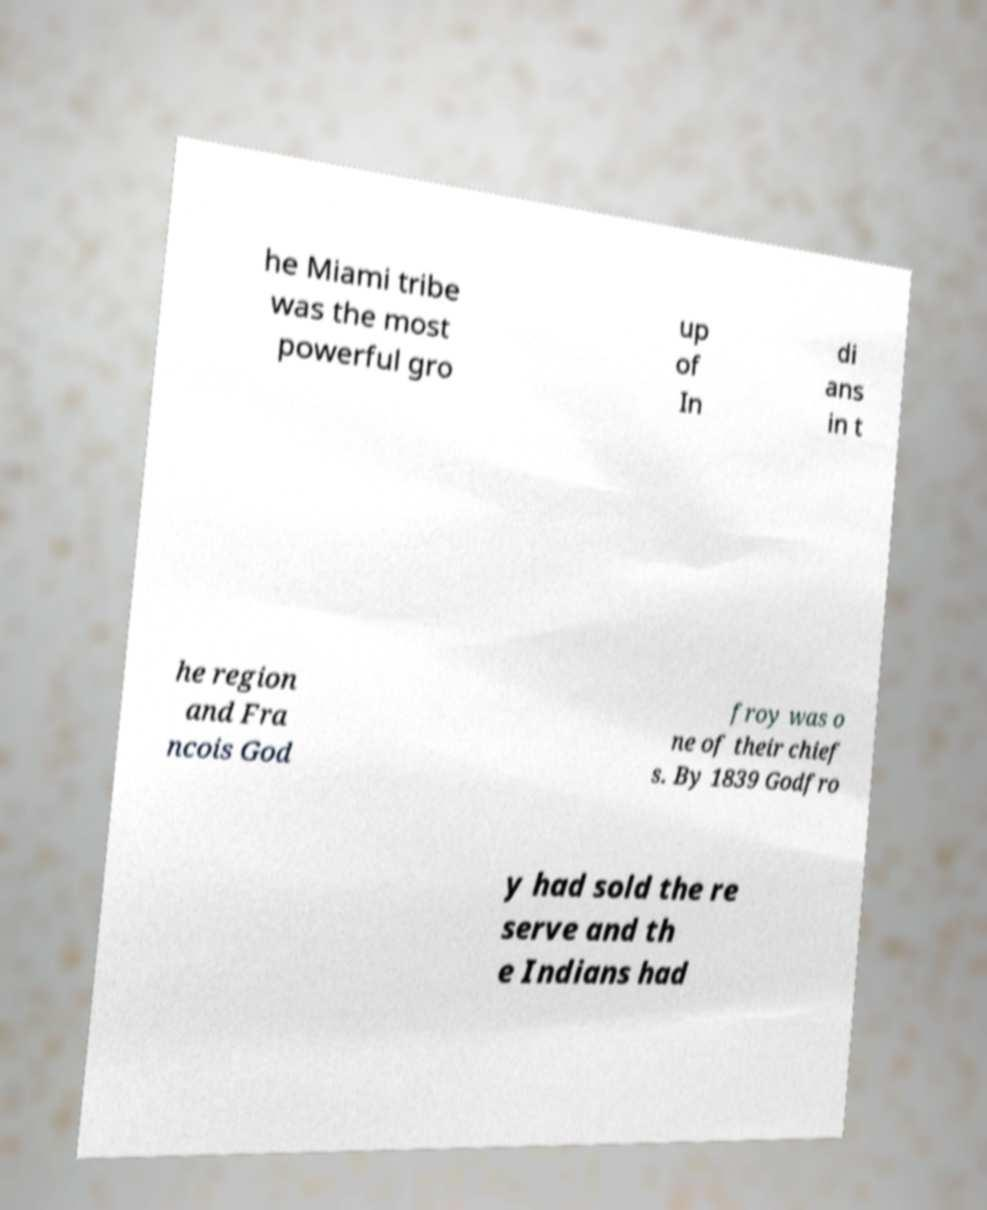Can you read and provide the text displayed in the image?This photo seems to have some interesting text. Can you extract and type it out for me? he Miami tribe was the most powerful gro up of In di ans in t he region and Fra ncois God froy was o ne of their chief s. By 1839 Godfro y had sold the re serve and th e Indians had 